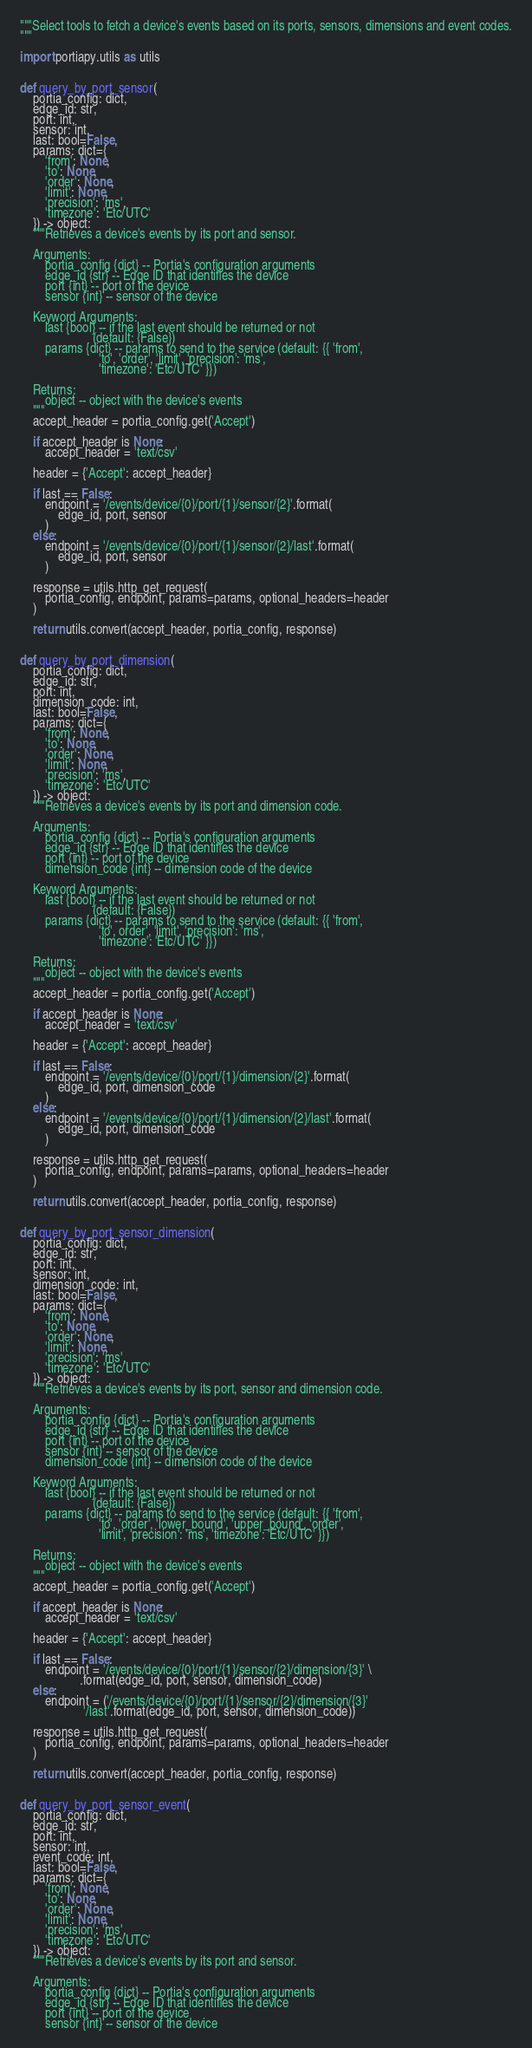<code> <loc_0><loc_0><loc_500><loc_500><_Python_>"""Select tools to fetch a device's events based on its ports, sensors, dimensions and event codes.
"""

import portiapy.utils as utils


def query_by_port_sensor(
    portia_config: dict,
    edge_id: str,
    port: int,
    sensor: int,
    last: bool=False,
    params: dict={
        'from': None,
        'to': None,
        'order': None,
        'limit': None,
        'precision': 'ms',
        'timezone': 'Etc/UTC'
    }) -> object:
    """Retrieves a device's events by its port and sensor.
    
    Arguments:
        portia_config {dict} -- Portia's configuration arguments
        edge_id {str} -- Edge ID that identifies the device
        port {int} -- port of the device
        sensor {int} -- sensor of the device
    
    Keyword Arguments:
        last {bool} -- if the last event should be returned or not
                       (default: {False})
        params {dict} -- params to send to the service (default: {{ 'from',
                         'to', 'order', 'limit', 'precision': 'ms',
                         'timezone': 'Etc/UTC' }})

    Returns:
        object -- object with the device's events
    """
    accept_header = portia_config.get('Accept')

    if accept_header is None:
        accept_header = 'text/csv'

    header = {'Accept': accept_header}

    if last == False:
        endpoint = '/events/device/{0}/port/{1}/sensor/{2}'.format(
            edge_id, port, sensor
        )
    else:
        endpoint = '/events/device/{0}/port/{1}/sensor/{2}/last'.format(
            edge_id, port, sensor
        )

    response = utils.http_get_request(
        portia_config, endpoint, params=params, optional_headers=header
    )

    return utils.convert(accept_header, portia_config, response)


def query_by_port_dimension(
    portia_config: dict,
    edge_id: str,
    port: int,
    dimension_code: int,
    last: bool=False,
    params: dict={
        'from': None,
        'to': None,
        'order': None,
        'limit': None,
        'precision': 'ms',
        'timezone': 'Etc/UTC'
    }) -> object:
    """Retrieves a device's events by its port and dimension code.
    
    Arguments:
        portia_config {dict} -- Portia's configuration arguments
        edge_id {str} -- Edge ID that identifies the device
        port {int} -- port of the device
        dimension_code {int} -- dimension code of the device
    
    Keyword Arguments:
        last {bool} -- if the last event should be returned or not
                       (default: {False})
        params {dict} -- params to send to the service (default: {{ 'from',
                         'to', order', 'limit', 'precision': 'ms',
                         'timezone': 'Etc/UTC' }})

    Returns:
        object -- object with the device's events
    """
    accept_header = portia_config.get('Accept')

    if accept_header is None:
        accept_header = 'text/csv'

    header = {'Accept': accept_header}

    if last == False:
        endpoint = '/events/device/{0}/port/{1}/dimension/{2}'.format(
            edge_id, port, dimension_code
        )
    else:
        endpoint = '/events/device/{0}/port/{1}/dimension/{2}/last'.format(
            edge_id, port, dimension_code
        )

    response = utils.http_get_request(
        portia_config, endpoint, params=params, optional_headers=header
    )

    return utils.convert(accept_header, portia_config, response)


def query_by_port_sensor_dimension(
    portia_config: dict,
    edge_id: str,
    port: int,
    sensor: int,
    dimension_code: int,
    last: bool=False,
    params: dict={
        'from': None,
        'to': None,
        'order': None,
        'limit': None,
        'precision': 'ms',
        'timezone': 'Etc/UTC'
    }) -> object:
    """Retrieves a device's events by its port, sensor and dimension code.
    
    Arguments:
        portia_config {dict} -- Portia's configuration arguments
        edge_id {str} -- Edge ID that identifies the device
        port {int} -- port of the device
        sensor {int} -- sensor of the device
        dimension_code {int} -- dimension code of the device
    
    Keyword Arguments:
        last {bool} -- if the last event should be returned or not
                       (default: {False})
        params {dict} -- params to send to the service (default: {{ 'from',
                         'to', 'order', 'lower_bound', 'upper_bound', 'order',
                         'limit', 'precision': 'ms', 'timezone': 'Etc/UTC' }})

    Returns:
        object -- object with the device's events
    """
    accept_header = portia_config.get('Accept')

    if accept_header is None:
        accept_header = 'text/csv'

    header = {'Accept': accept_header}

    if last == False:
        endpoint = '/events/device/{0}/port/{1}/sensor/{2}/dimension/{3}' \
                   .format(edge_id, port, sensor, dimension_code)
    else:
        endpoint = ('/events/device/{0}/port/{1}/sensor/{2}/dimension/{3}'
                    '/last'.format(edge_id, port, sensor, dimension_code))

    response = utils.http_get_request(
        portia_config, endpoint, params=params, optional_headers=header
    )

    return utils.convert(accept_header, portia_config, response)


def query_by_port_sensor_event(
    portia_config: dict,
    edge_id: str,
    port: int,
    sensor: int,
    event_code: int,
    last: bool=False,
    params: dict={
        'from': None,
        'to': None,
        'order': None,
        'limit': None,
        'precision': 'ms',
        'timezone': 'Etc/UTC'
    }) -> object:
    """Retrieves a device's events by its port and sensor.
    
    Arguments:
        portia_config {dict} -- Portia's configuration arguments
        edge_id {str} -- Edge ID that identifies the device
        port {int} -- port of the device
        sensor {int} -- sensor of the device</code> 